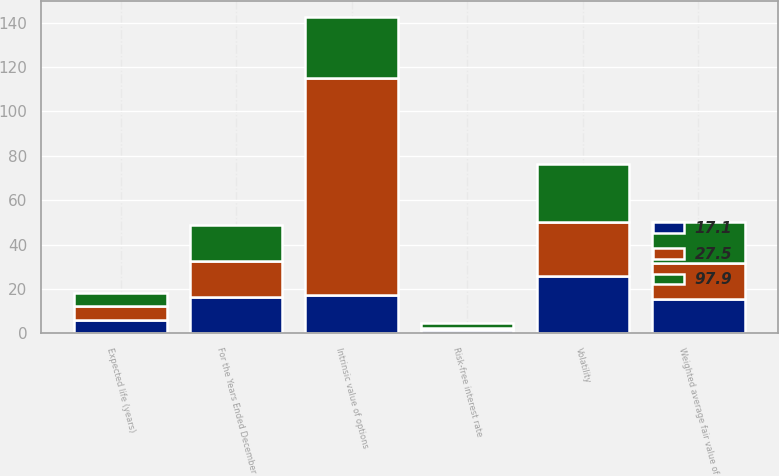<chart> <loc_0><loc_0><loc_500><loc_500><stacked_bar_chart><ecel><fcel>For the Years Ended December<fcel>Volatility<fcel>Risk-free interest rate<fcel>Expected life (years)<fcel>Weighted average fair value of<fcel>Intrinsic value of options<nl><fcel>27.5<fcel>16.33<fcel>24.5<fcel>1.1<fcel>6.1<fcel>16.33<fcel>97.9<nl><fcel>17.1<fcel>16.33<fcel>25.6<fcel>1.5<fcel>6.1<fcel>15.4<fcel>17.1<nl><fcel>97.9<fcel>16.33<fcel>26.1<fcel>2.2<fcel>6.1<fcel>18.33<fcel>27.5<nl></chart> 